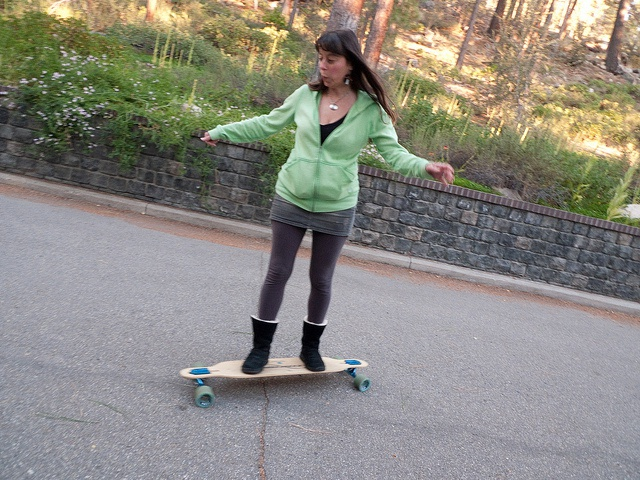Describe the objects in this image and their specific colors. I can see people in olive, black, darkgray, gray, and turquoise tones and skateboard in olive, lightgray, darkgray, and gray tones in this image. 